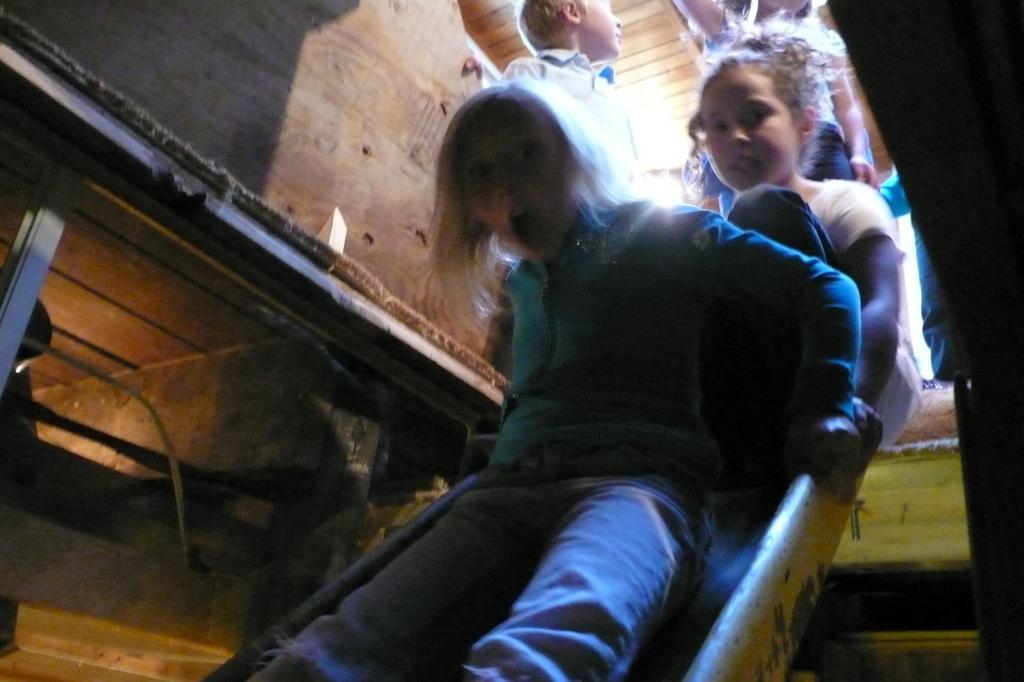Could you give a brief overview of what you see in this image? Few children are playing with the slope, this person wore t-shirt, trouser, it is a wooden house. 